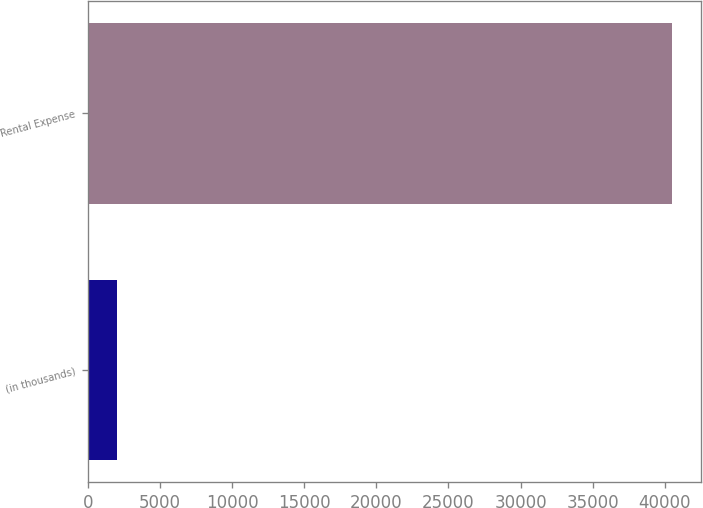Convert chart. <chart><loc_0><loc_0><loc_500><loc_500><bar_chart><fcel>(in thousands)<fcel>Rental Expense<nl><fcel>2009<fcel>40515<nl></chart> 